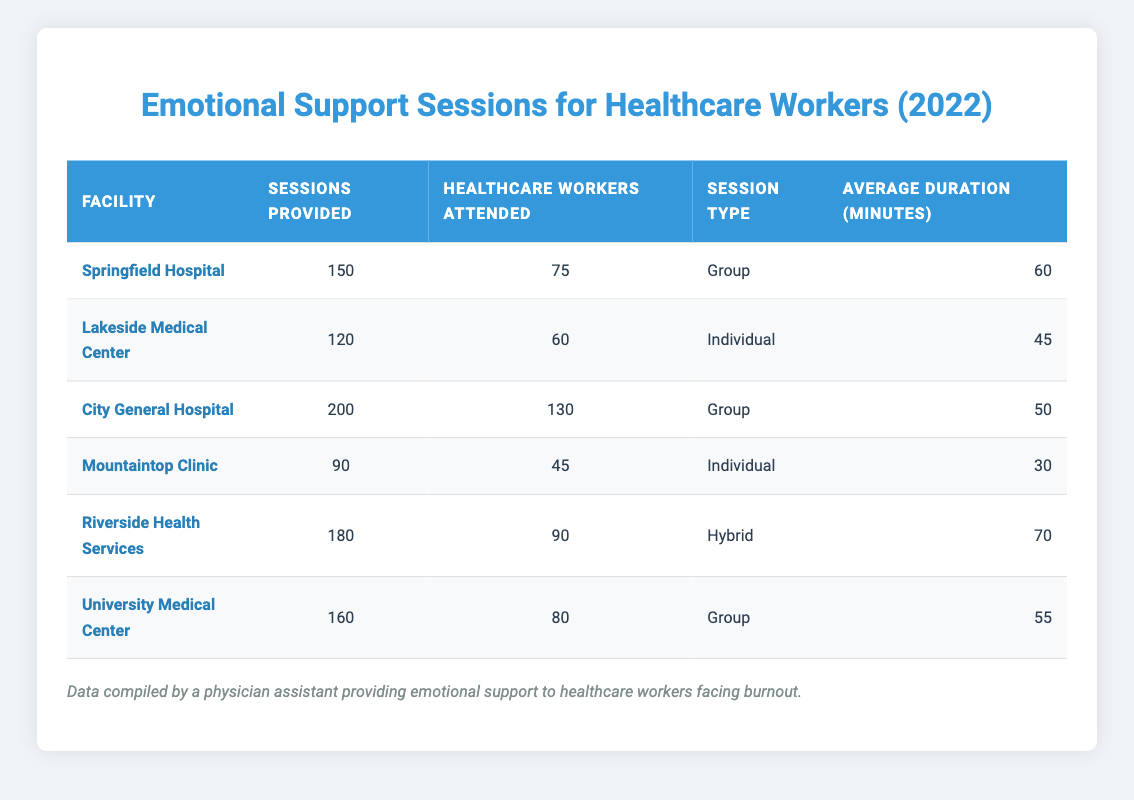What facility provided the highest number of emotional support sessions? By examining the "Sessions Provided" column in the table, we see that City General Hospital has the highest number, with a total of 200 sessions.
Answer: City General Hospital How many healthcare workers attended sessions at Lakeside Medical Center? The "Healthcare Workers Attended" column tells us that Lakeside Medical Center had 60 healthcare workers attending the sessions.
Answer: 60 What is the average session duration for emotional support sessions across all facilities? To find the average duration, we sum the average duration of all facilities: 60 + 45 + 50 + 30 + 70 + 55 = 310 minutes. Then, we divide by the number of facilities (6): 310 / 6 = 51.67 minutes, which rounds to approximately 52 minutes.
Answer: 52 Did Mountaintop Clinic provide more sessions than Lakeside Medical Center? Mountaintop Clinic provided 90 sessions while Lakeside Medical Center provided 120 sessions. Therefore, Mountaintop Clinic provided fewer sessions.
Answer: No What is the total number of healthcare workers that attended sessions at all facilities combined? We need to sum the "Healthcare Workers Attended" values for all facilities: 75 + 60 + 130 + 45 + 90 + 80 = 480.
Answer: 480 Which facility had the shortest average session duration? By looking at the "Average Duration" column, we can see that Mountaintop Clinic had the shortest average session duration at 30 minutes.
Answer: Mountaintop Clinic How many more sessions did Riverside Health Services provide compared to Mountaintop Clinic? Riverside Health Services provided 180 sessions while Mountaintop Clinic provided 90. We subtract: 180 - 90 = 90 more sessions.
Answer: 90 Is it true that University Medical Center provided fewer sessions than Springfield Hospital? University Medical Center provided 160 sessions, while Springfield Hospital provided 150 sessions. This means University Medical Center provided more sessions than Springfield Hospital.
Answer: No What is the sum of healthcare workers who attended sessions at group-type facilities? Group-type facilities are Springfield Hospital, City General Hospital, and University Medical Center, with attendees of 75, 130, and 80, respectively. Summing these: 75 + 130 + 80 = 285.
Answer: 285 